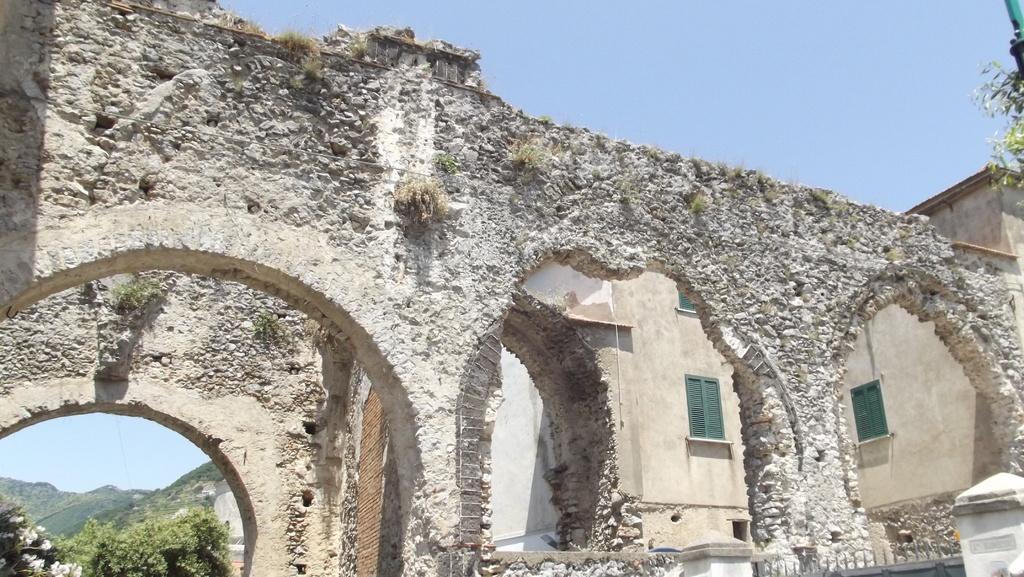Can you describe this image briefly? In the center of the image we can see one building with windows, pillars and arches. At the top right side of the image, we can see leaves and some object. In the background, we can see the sky, hills and trees. 